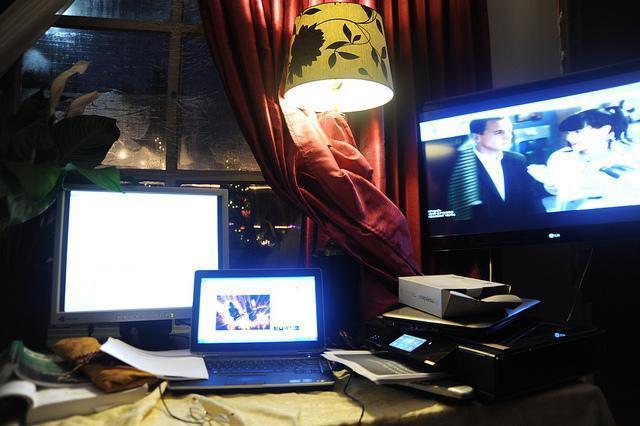How many computers are in the photo?
Give a very brief answer. 2. How many tvs can you see?
Give a very brief answer. 3. How many people are there?
Give a very brief answer. 2. 